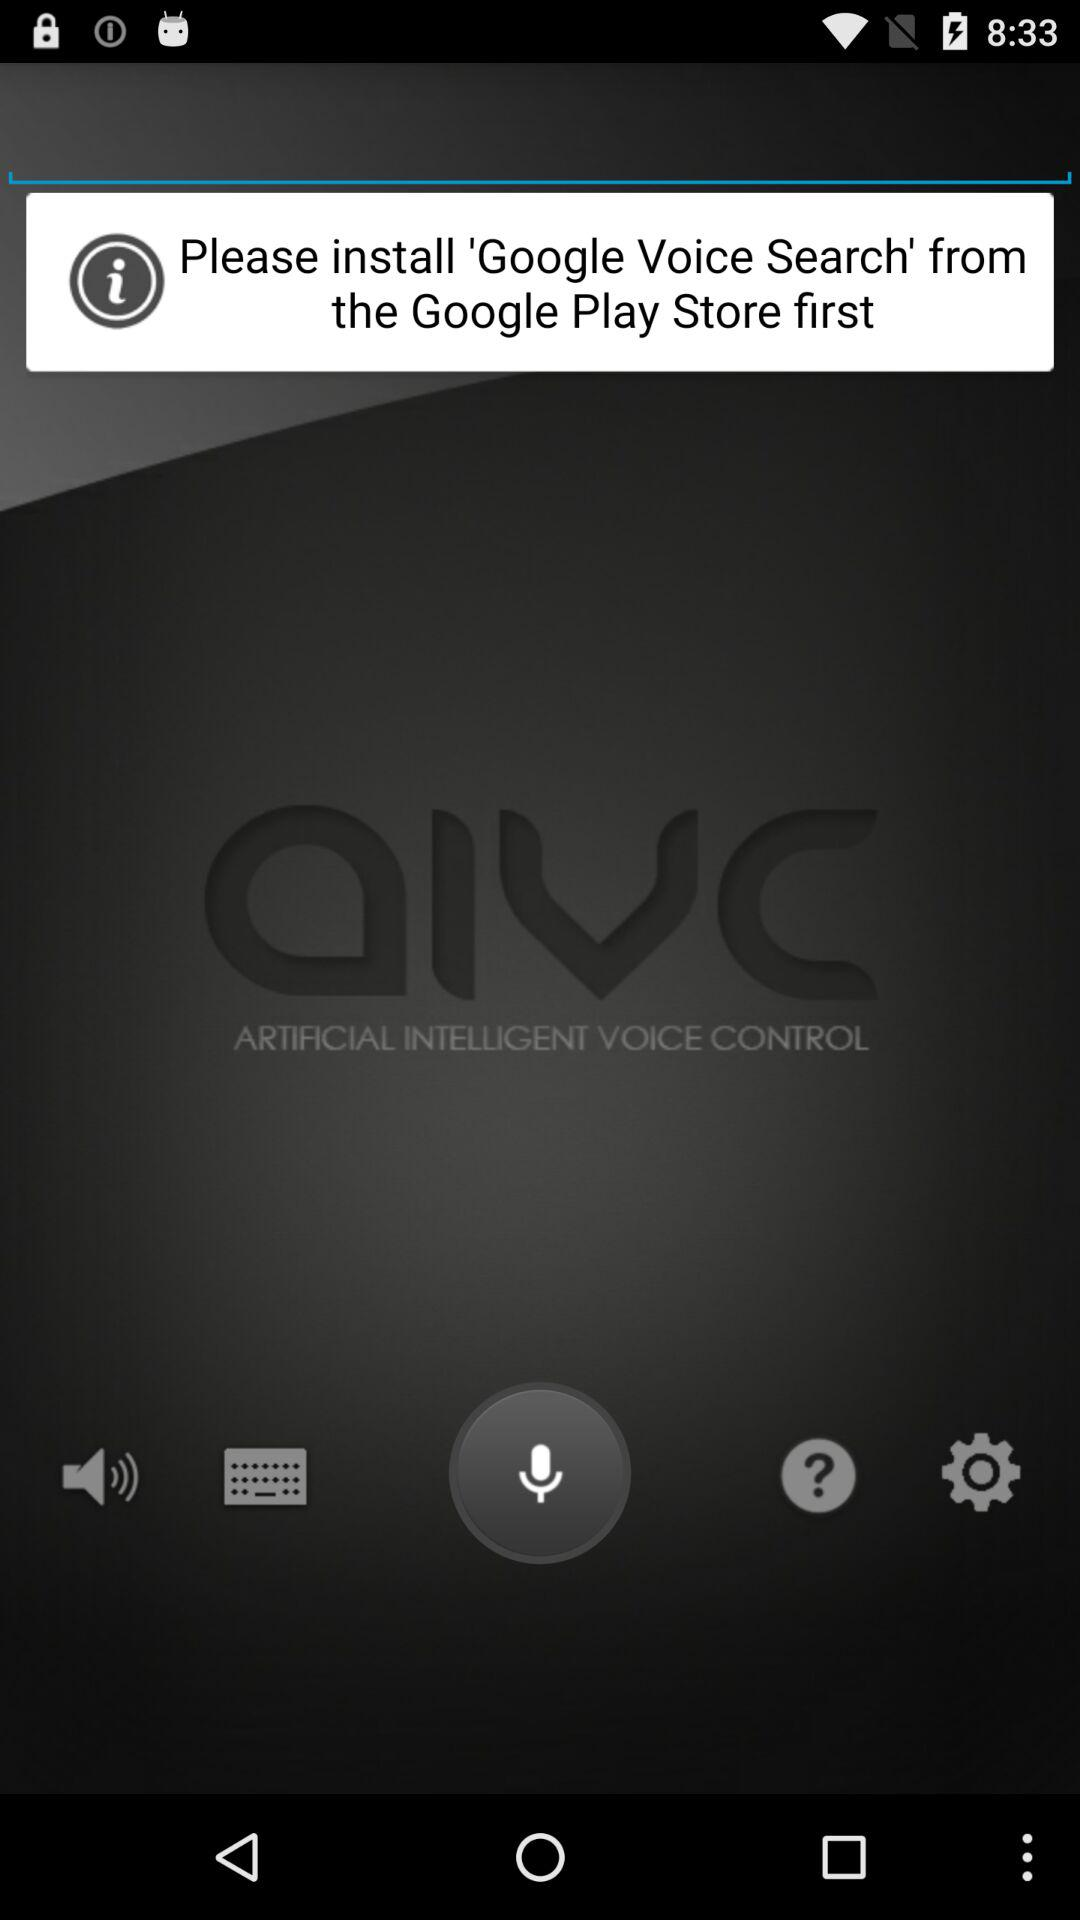How do I access the "Google Play Store"?
When the provided information is insufficient, respond with <no answer>. <no answer> 